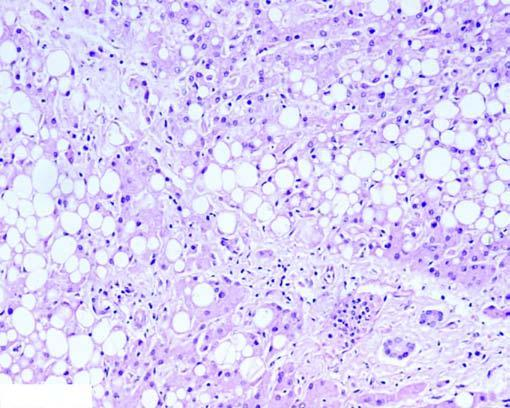what show multiple small vacuoles in the cytoplasm (microvesicles)?
Answer the question using a single word or phrase. Others hepatocytes 